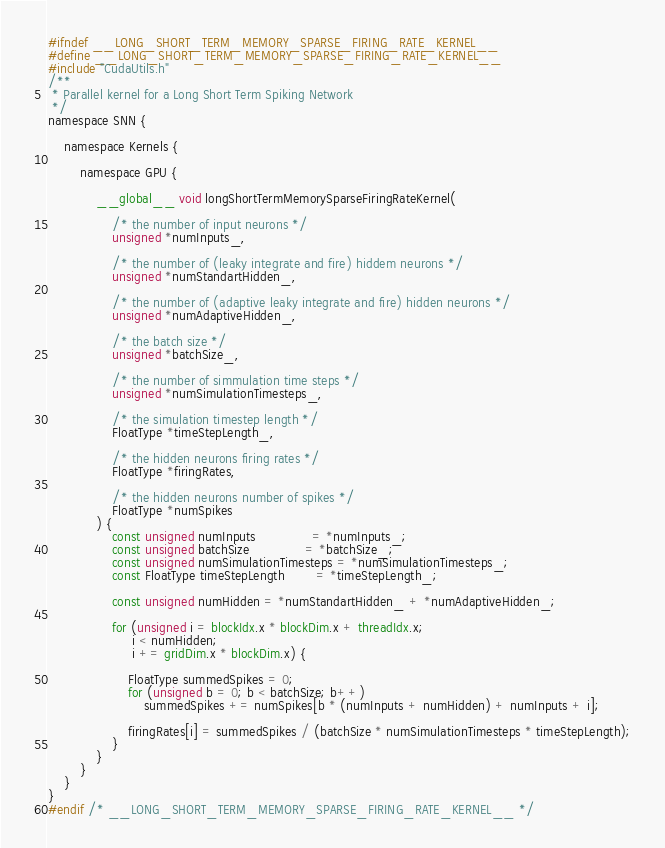<code> <loc_0><loc_0><loc_500><loc_500><_Cuda_>#ifndef __LONG_SHORT_TERM_MEMORY_SPARSE_FIRING_RATE_KERNEL__
#define __LONG_SHORT_TERM_MEMORY_SPARSE_FIRING_RATE_KERNEL__
#include "CudaUtils.h"
/**
 * Parallel kernel for a Long Short Term Spiking Network
 */
namespace SNN {

    namespace Kernels {

        namespace GPU {

            __global__ void longShortTermMemorySparseFiringRateKernel(

                /* the number of input neurons */
                unsigned *numInputs_,

                /* the number of (leaky integrate and fire) hiddem neurons */
                unsigned *numStandartHidden_,

                /* the number of (adaptive leaky integrate and fire) hidden neurons */
                unsigned *numAdaptiveHidden_,

                /* the batch size */
                unsigned *batchSize_,

                /* the number of simmulation time steps */
                unsigned *numSimulationTimesteps_,

                /* the simulation timestep length */
                FloatType *timeStepLength_,

                /* the hidden neurons firing rates */
                FloatType *firingRates,

                /* the hidden neurons number of spikes */
                FloatType *numSpikes
            ) {
                const unsigned numInputs              = *numInputs_;
                const unsigned batchSize              = *batchSize_;
                const unsigned numSimulationTimesteps = *numSimulationTimesteps_;
                const FloatType timeStepLength        = *timeStepLength_;

                const unsigned numHidden = *numStandartHidden_ + *numAdaptiveHidden_;
                
                for (unsigned i = blockIdx.x * blockDim.x + threadIdx.x; 
                     i < numHidden;
                     i += gridDim.x * blockDim.x) {

                    FloatType summedSpikes = 0;
                    for (unsigned b = 0; b < batchSize; b++)
                        summedSpikes += numSpikes[b * (numInputs + numHidden) + numInputs + i];

                    firingRates[i] = summedSpikes / (batchSize * numSimulationTimesteps * timeStepLength);
                }
            }
        }
    }
}
#endif /* __LONG_SHORT_TERM_MEMORY_SPARSE_FIRING_RATE_KERNEL__ */
</code> 